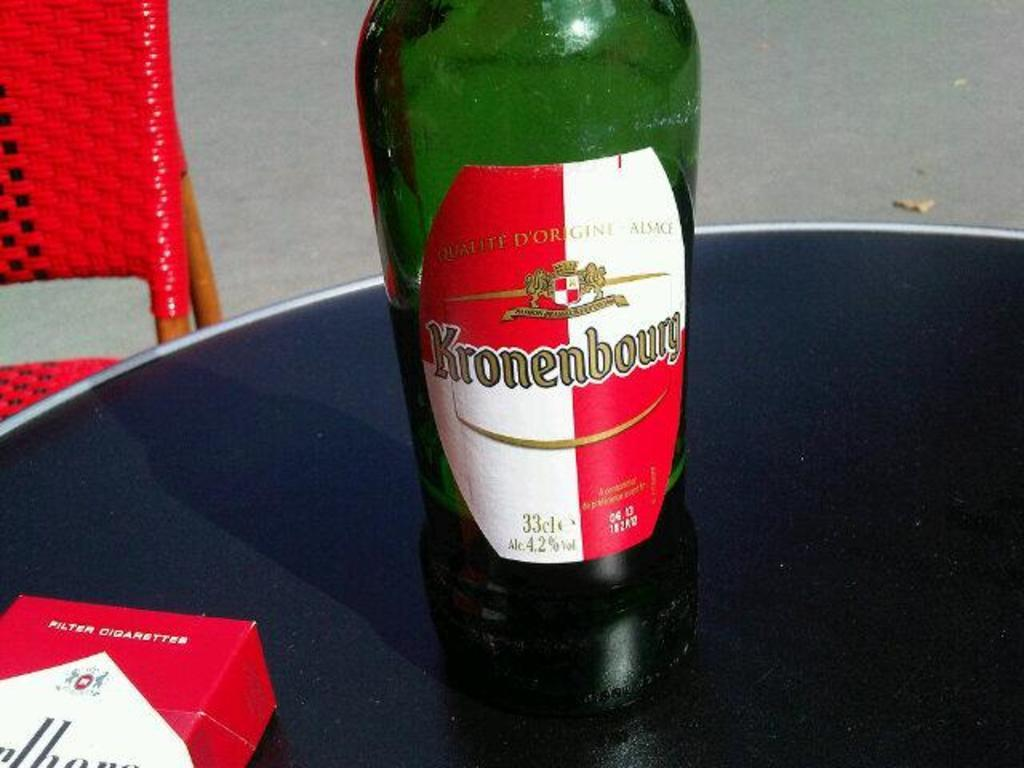<image>
Write a terse but informative summary of the picture. A beer bottle placed on a round table with a label that says Kronenbourg. 